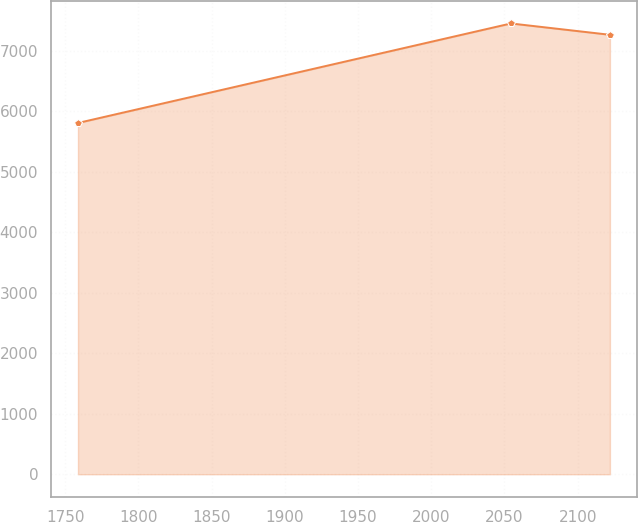<chart> <loc_0><loc_0><loc_500><loc_500><line_chart><ecel><fcel>Unnamed: 1<nl><fcel>1758.68<fcel>5808.71<nl><fcel>2054.42<fcel>7454.14<nl><fcel>2122.03<fcel>7266.75<nl></chart> 